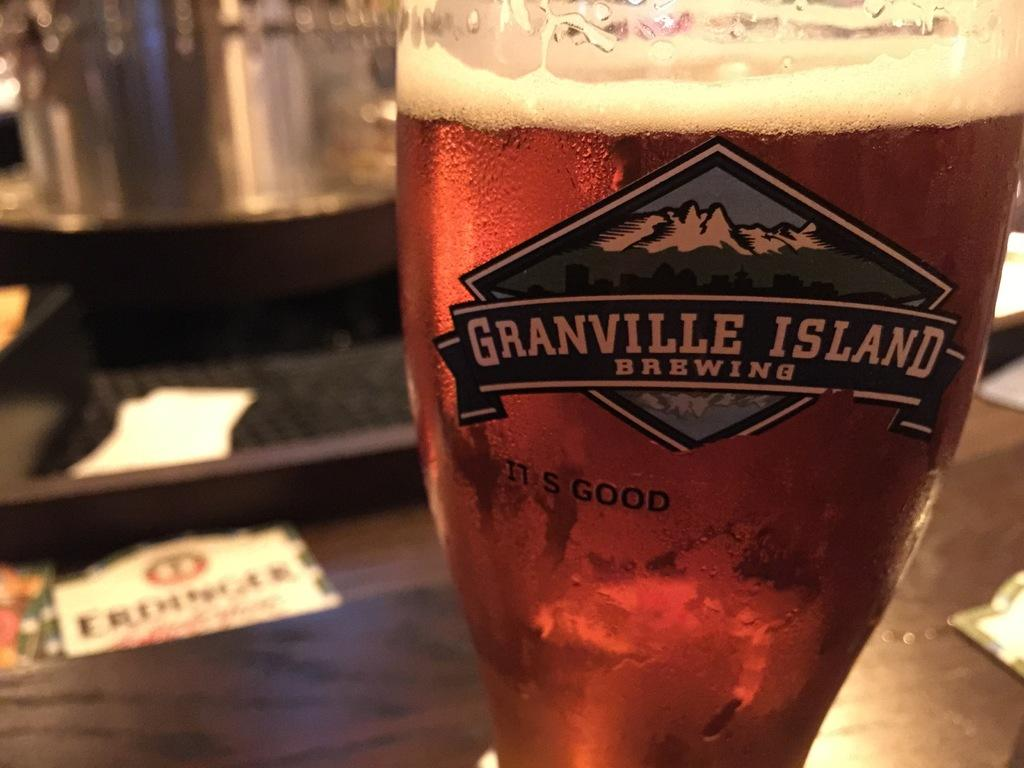Provide a one-sentence caption for the provided image. Granville Island brews good beer and has a mountain for their logo. 